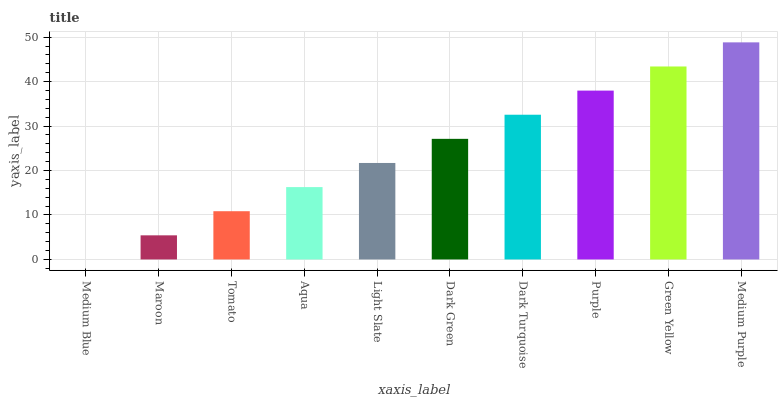Is Medium Blue the minimum?
Answer yes or no. Yes. Is Medium Purple the maximum?
Answer yes or no. Yes. Is Maroon the minimum?
Answer yes or no. No. Is Maroon the maximum?
Answer yes or no. No. Is Maroon greater than Medium Blue?
Answer yes or no. Yes. Is Medium Blue less than Maroon?
Answer yes or no. Yes. Is Medium Blue greater than Maroon?
Answer yes or no. No. Is Maroon less than Medium Blue?
Answer yes or no. No. Is Dark Green the high median?
Answer yes or no. Yes. Is Light Slate the low median?
Answer yes or no. Yes. Is Dark Turquoise the high median?
Answer yes or no. No. Is Aqua the low median?
Answer yes or no. No. 